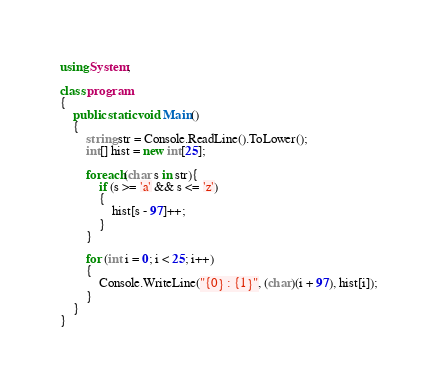<code> <loc_0><loc_0><loc_500><loc_500><_C#_>using System;

class program
{
    public static void Main()
    {
        string str = Console.ReadLine().ToLower();
        int[] hist = new int[25];

        foreach(char s in str){
            if (s >= 'a' && s <= 'z')
            {
                hist[s - 97]++;
            }
        }

        for (int i = 0; i < 25; i++)
        {
            Console.WriteLine("{0} : {1}", (char)(i + 97), hist[i]);
        }
    }
}</code> 